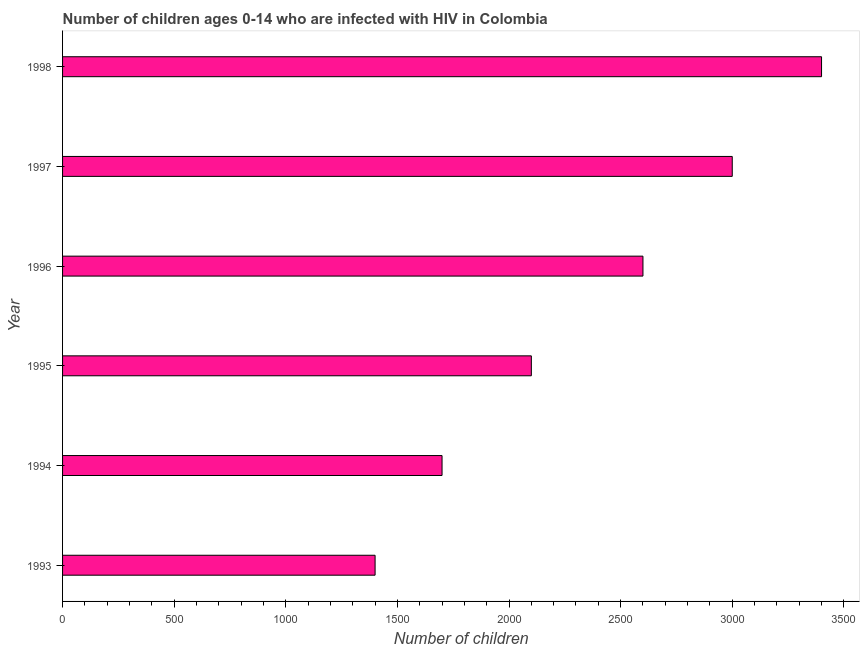Does the graph contain grids?
Your response must be concise. No. What is the title of the graph?
Ensure brevity in your answer.  Number of children ages 0-14 who are infected with HIV in Colombia. What is the label or title of the X-axis?
Your response must be concise. Number of children. What is the number of children living with hiv in 1998?
Your answer should be very brief. 3400. Across all years, what is the maximum number of children living with hiv?
Make the answer very short. 3400. Across all years, what is the minimum number of children living with hiv?
Your response must be concise. 1400. In which year was the number of children living with hiv maximum?
Ensure brevity in your answer.  1998. What is the sum of the number of children living with hiv?
Provide a short and direct response. 1.42e+04. What is the difference between the number of children living with hiv in 1994 and 1995?
Offer a very short reply. -400. What is the average number of children living with hiv per year?
Offer a very short reply. 2366. What is the median number of children living with hiv?
Offer a very short reply. 2350. In how many years, is the number of children living with hiv greater than 2100 ?
Provide a succinct answer. 3. Do a majority of the years between 1997 and 1996 (inclusive) have number of children living with hiv greater than 3100 ?
Your answer should be very brief. No. What is the ratio of the number of children living with hiv in 1993 to that in 1998?
Your answer should be compact. 0.41. What is the difference between the highest and the second highest number of children living with hiv?
Provide a short and direct response. 400. What is the difference between the highest and the lowest number of children living with hiv?
Provide a succinct answer. 2000. Are all the bars in the graph horizontal?
Provide a succinct answer. Yes. How many years are there in the graph?
Keep it short and to the point. 6. What is the difference between two consecutive major ticks on the X-axis?
Keep it short and to the point. 500. What is the Number of children in 1993?
Offer a very short reply. 1400. What is the Number of children of 1994?
Offer a terse response. 1700. What is the Number of children of 1995?
Your answer should be very brief. 2100. What is the Number of children of 1996?
Keep it short and to the point. 2600. What is the Number of children of 1997?
Offer a terse response. 3000. What is the Number of children of 1998?
Provide a short and direct response. 3400. What is the difference between the Number of children in 1993 and 1994?
Keep it short and to the point. -300. What is the difference between the Number of children in 1993 and 1995?
Your response must be concise. -700. What is the difference between the Number of children in 1993 and 1996?
Provide a succinct answer. -1200. What is the difference between the Number of children in 1993 and 1997?
Provide a succinct answer. -1600. What is the difference between the Number of children in 1993 and 1998?
Provide a short and direct response. -2000. What is the difference between the Number of children in 1994 and 1995?
Your answer should be very brief. -400. What is the difference between the Number of children in 1994 and 1996?
Ensure brevity in your answer.  -900. What is the difference between the Number of children in 1994 and 1997?
Offer a terse response. -1300. What is the difference between the Number of children in 1994 and 1998?
Offer a terse response. -1700. What is the difference between the Number of children in 1995 and 1996?
Provide a succinct answer. -500. What is the difference between the Number of children in 1995 and 1997?
Ensure brevity in your answer.  -900. What is the difference between the Number of children in 1995 and 1998?
Offer a very short reply. -1300. What is the difference between the Number of children in 1996 and 1997?
Your response must be concise. -400. What is the difference between the Number of children in 1996 and 1998?
Give a very brief answer. -800. What is the difference between the Number of children in 1997 and 1998?
Offer a very short reply. -400. What is the ratio of the Number of children in 1993 to that in 1994?
Keep it short and to the point. 0.82. What is the ratio of the Number of children in 1993 to that in 1995?
Provide a short and direct response. 0.67. What is the ratio of the Number of children in 1993 to that in 1996?
Provide a short and direct response. 0.54. What is the ratio of the Number of children in 1993 to that in 1997?
Offer a terse response. 0.47. What is the ratio of the Number of children in 1993 to that in 1998?
Provide a succinct answer. 0.41. What is the ratio of the Number of children in 1994 to that in 1995?
Offer a very short reply. 0.81. What is the ratio of the Number of children in 1994 to that in 1996?
Offer a terse response. 0.65. What is the ratio of the Number of children in 1994 to that in 1997?
Your answer should be very brief. 0.57. What is the ratio of the Number of children in 1995 to that in 1996?
Your answer should be compact. 0.81. What is the ratio of the Number of children in 1995 to that in 1997?
Your answer should be very brief. 0.7. What is the ratio of the Number of children in 1995 to that in 1998?
Offer a terse response. 0.62. What is the ratio of the Number of children in 1996 to that in 1997?
Offer a terse response. 0.87. What is the ratio of the Number of children in 1996 to that in 1998?
Make the answer very short. 0.77. What is the ratio of the Number of children in 1997 to that in 1998?
Offer a terse response. 0.88. 